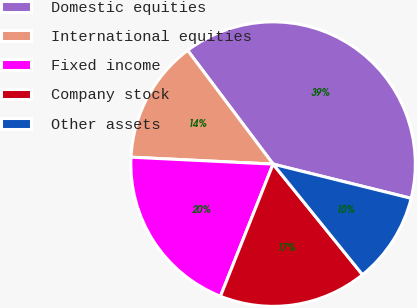Convert chart. <chart><loc_0><loc_0><loc_500><loc_500><pie_chart><fcel>Domestic equities<fcel>International equities<fcel>Fixed income<fcel>Company stock<fcel>Other assets<nl><fcel>39.12%<fcel>13.97%<fcel>19.74%<fcel>16.85%<fcel>10.31%<nl></chart> 